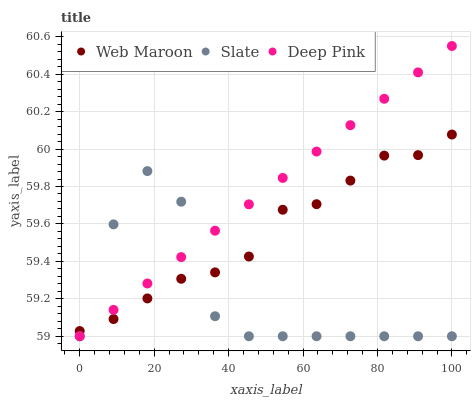Does Slate have the minimum area under the curve?
Answer yes or no. Yes. Does Deep Pink have the maximum area under the curve?
Answer yes or no. Yes. Does Web Maroon have the minimum area under the curve?
Answer yes or no. No. Does Web Maroon have the maximum area under the curve?
Answer yes or no. No. Is Deep Pink the smoothest?
Answer yes or no. Yes. Is Slate the roughest?
Answer yes or no. Yes. Is Web Maroon the smoothest?
Answer yes or no. No. Is Web Maroon the roughest?
Answer yes or no. No. Does Slate have the lowest value?
Answer yes or no. Yes. Does Web Maroon have the lowest value?
Answer yes or no. No. Does Deep Pink have the highest value?
Answer yes or no. Yes. Does Web Maroon have the highest value?
Answer yes or no. No. Does Slate intersect Deep Pink?
Answer yes or no. Yes. Is Slate less than Deep Pink?
Answer yes or no. No. Is Slate greater than Deep Pink?
Answer yes or no. No. 